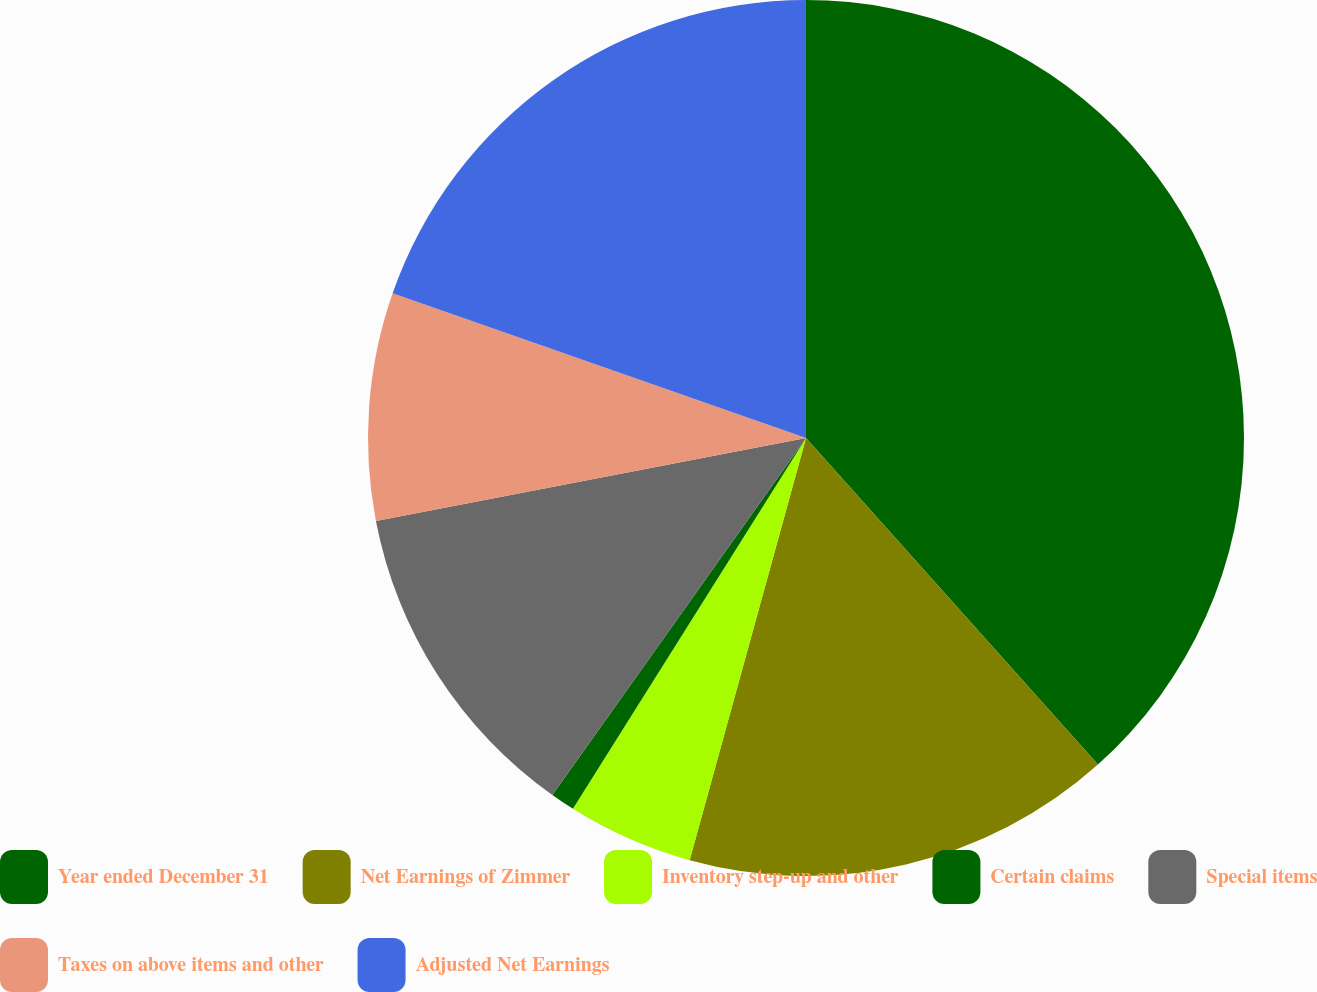Convert chart. <chart><loc_0><loc_0><loc_500><loc_500><pie_chart><fcel>Year ended December 31<fcel>Net Earnings of Zimmer<fcel>Inventory step-up and other<fcel>Certain claims<fcel>Special items<fcel>Taxes on above items and other<fcel>Adjusted Net Earnings<nl><fcel>38.39%<fcel>15.89%<fcel>4.65%<fcel>0.9%<fcel>12.14%<fcel>8.39%<fcel>19.64%<nl></chart> 